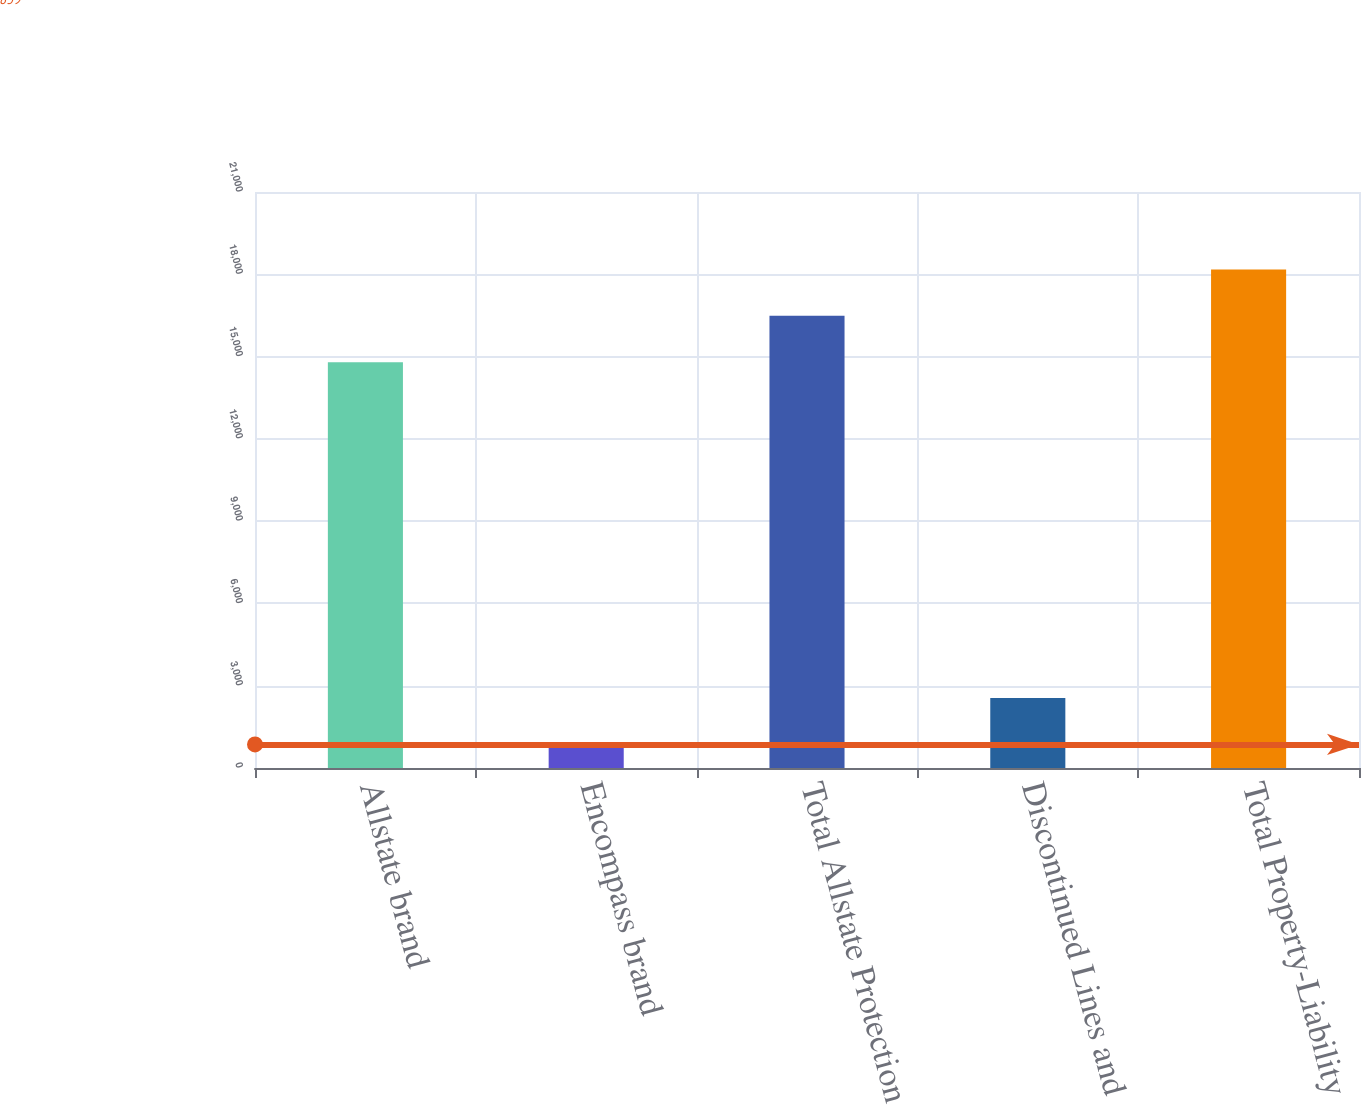<chart> <loc_0><loc_0><loc_500><loc_500><bar_chart><fcel>Allstate brand<fcel>Encompass brand<fcel>Total Allstate Protection<fcel>Discontinued Lines and<fcel>Total Property-Liability<nl><fcel>14792<fcel>859<fcel>16484.8<fcel>2551.8<fcel>18177.6<nl></chart> 